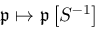<formula> <loc_0><loc_0><loc_500><loc_500>{ \mathfrak { p } } \mapsto { \mathfrak { p } } \left [ S ^ { - 1 } \right ]</formula> 